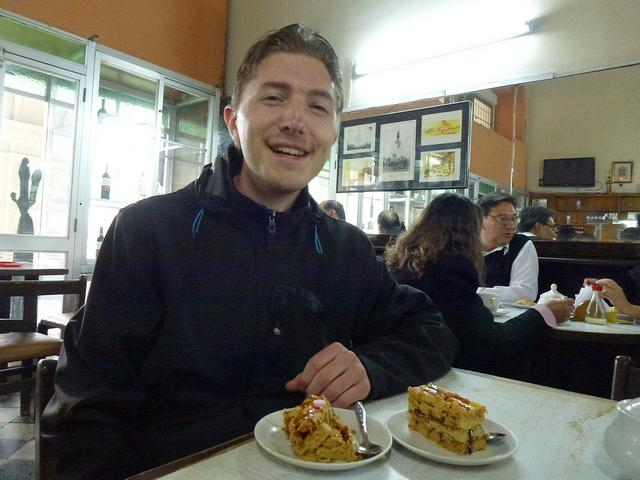What type food is this man enjoying? cake 